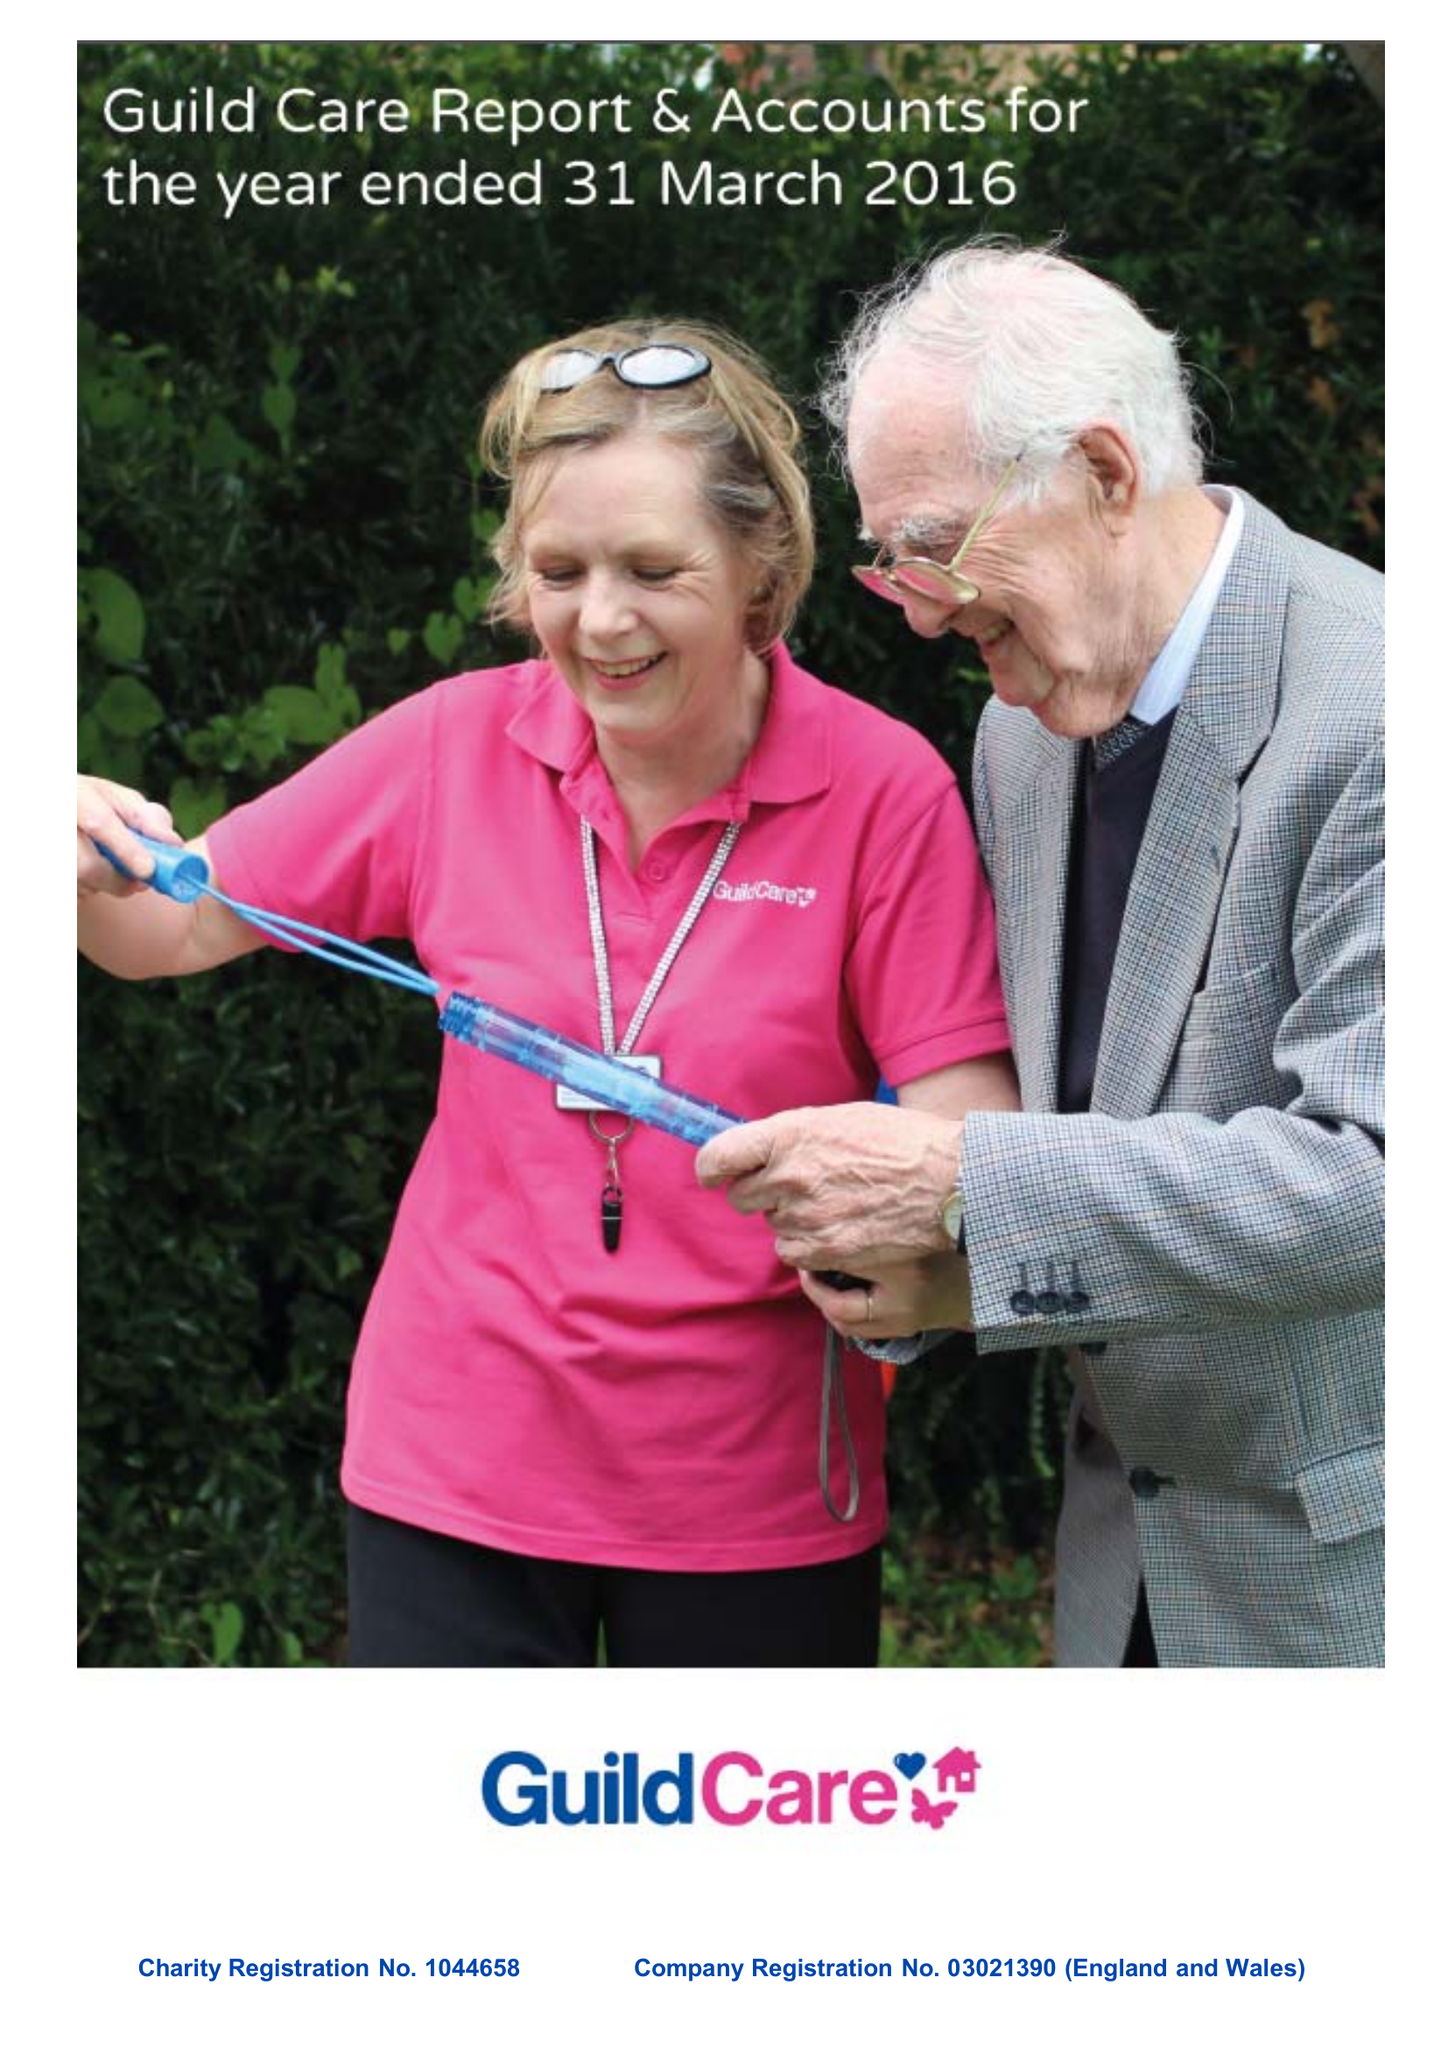What is the value for the charity_name?
Answer the question using a single word or phrase. Guild Care 